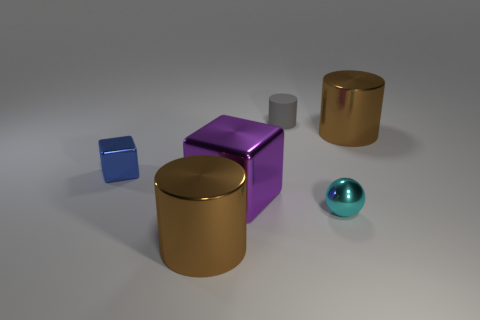Do the objects in the image seem to be arranged in any particular pattern? The objects are not arranged in a clear pattern but are placed with ample space around them. It seems to be a random distribution without a specific order or symmetry. 